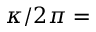Convert formula to latex. <formula><loc_0><loc_0><loc_500><loc_500>\kappa / 2 \pi =</formula> 